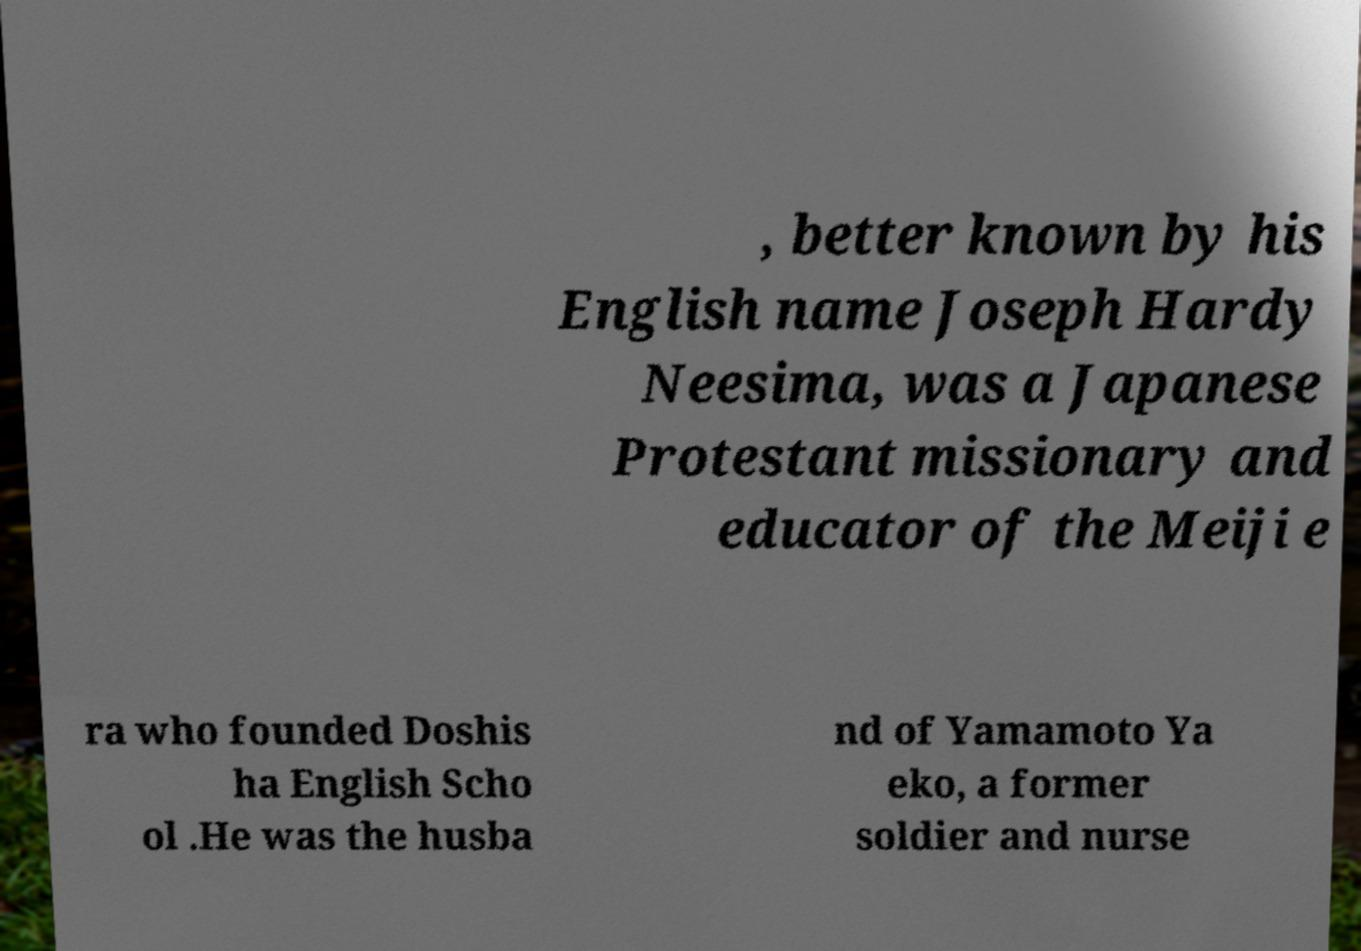Can you accurately transcribe the text from the provided image for me? , better known by his English name Joseph Hardy Neesima, was a Japanese Protestant missionary and educator of the Meiji e ra who founded Doshis ha English Scho ol .He was the husba nd of Yamamoto Ya eko, a former soldier and nurse 